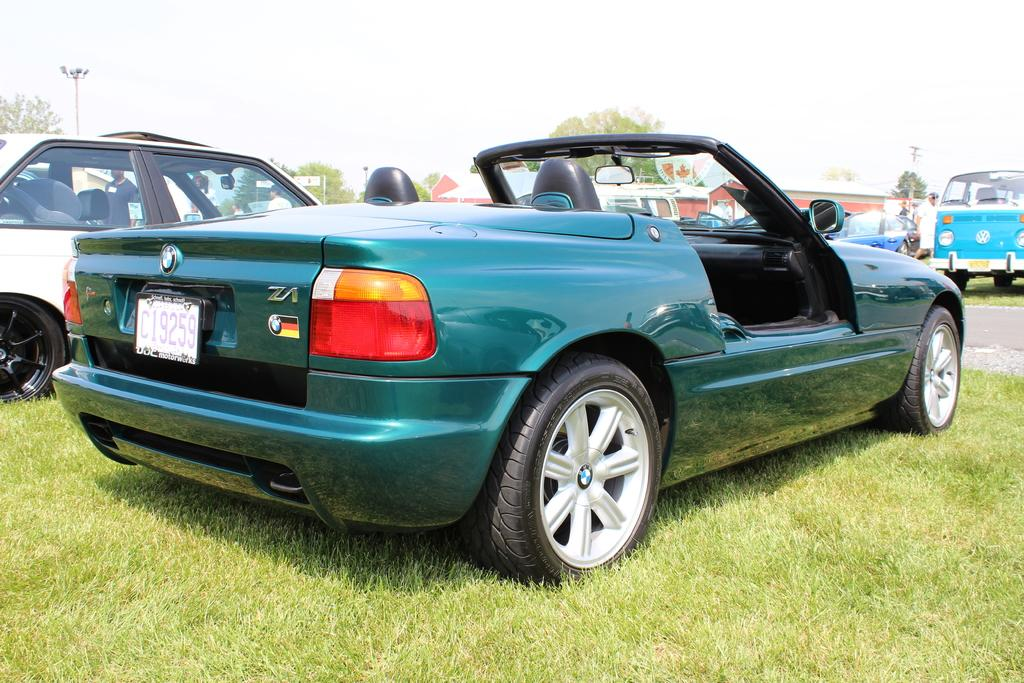What is the main subject in the foreground of the image? There is a car in the foreground of the image. Where is the car located? The car is on a grassland. What can be seen in the background of the image? There are cars, people, houses, poles, trees, and the sky visible in the background of the image. What type of twig is being used as bait by the people in the image? There is no twig or bait present in the image; the people are not engaged in any activity involving twigs or bait. 